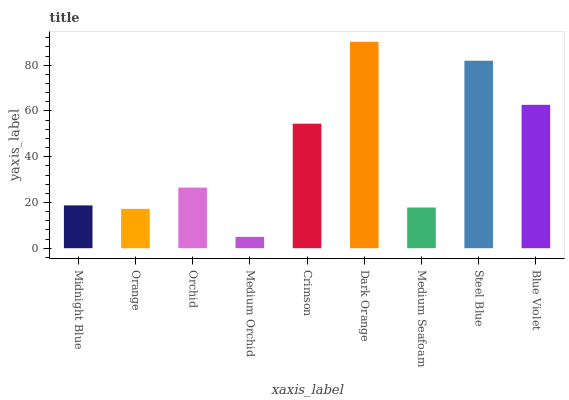Is Medium Orchid the minimum?
Answer yes or no. Yes. Is Dark Orange the maximum?
Answer yes or no. Yes. Is Orange the minimum?
Answer yes or no. No. Is Orange the maximum?
Answer yes or no. No. Is Midnight Blue greater than Orange?
Answer yes or no. Yes. Is Orange less than Midnight Blue?
Answer yes or no. Yes. Is Orange greater than Midnight Blue?
Answer yes or no. No. Is Midnight Blue less than Orange?
Answer yes or no. No. Is Orchid the high median?
Answer yes or no. Yes. Is Orchid the low median?
Answer yes or no. Yes. Is Orange the high median?
Answer yes or no. No. Is Medium Orchid the low median?
Answer yes or no. No. 